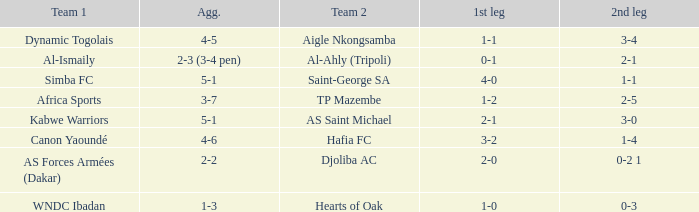What team played against Hafia FC (team 2)? Canon Yaoundé. 